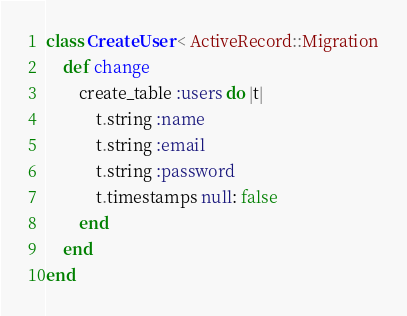<code> <loc_0><loc_0><loc_500><loc_500><_Ruby_>class CreateUser < ActiveRecord::Migration
	def change
		create_table :users do |t|
			t.string :name
			t.string :email
			t.string :password
			t.timestamps null: false
		end
	end
end</code> 